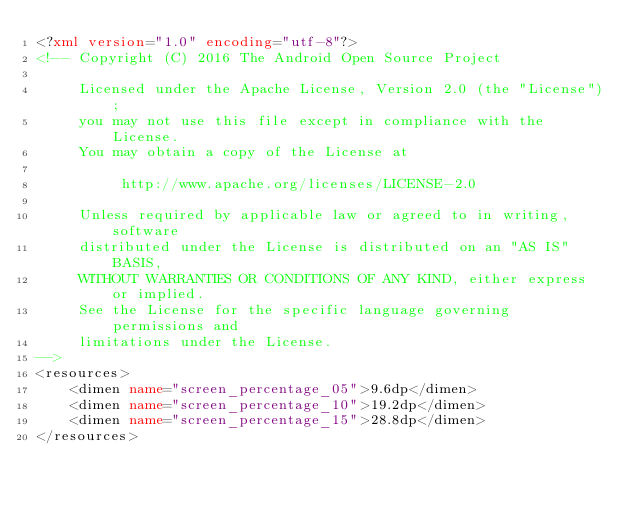<code> <loc_0><loc_0><loc_500><loc_500><_XML_><?xml version="1.0" encoding="utf-8"?>
<!-- Copyright (C) 2016 The Android Open Source Project

     Licensed under the Apache License, Version 2.0 (the "License");
     you may not use this file except in compliance with the License.
     You may obtain a copy of the License at

          http://www.apache.org/licenses/LICENSE-2.0

     Unless required by applicable law or agreed to in writing, software
     distributed under the License is distributed on an "AS IS" BASIS,
     WITHOUT WARRANTIES OR CONDITIONS OF ANY KIND, either express or implied.
     See the License for the specific language governing permissions and
     limitations under the License.
-->
<resources>
    <dimen name="screen_percentage_05">9.6dp</dimen>
    <dimen name="screen_percentage_10">19.2dp</dimen>
    <dimen name="screen_percentage_15">28.8dp</dimen>
</resources>
</code> 